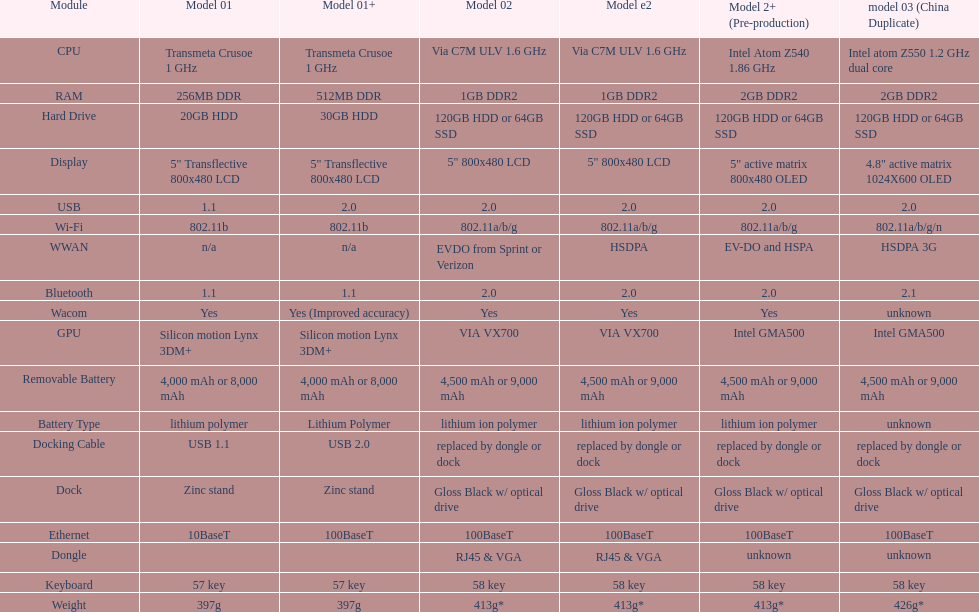How many models contain 2. 